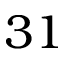<formula> <loc_0><loc_0><loc_500><loc_500>3 1</formula> 